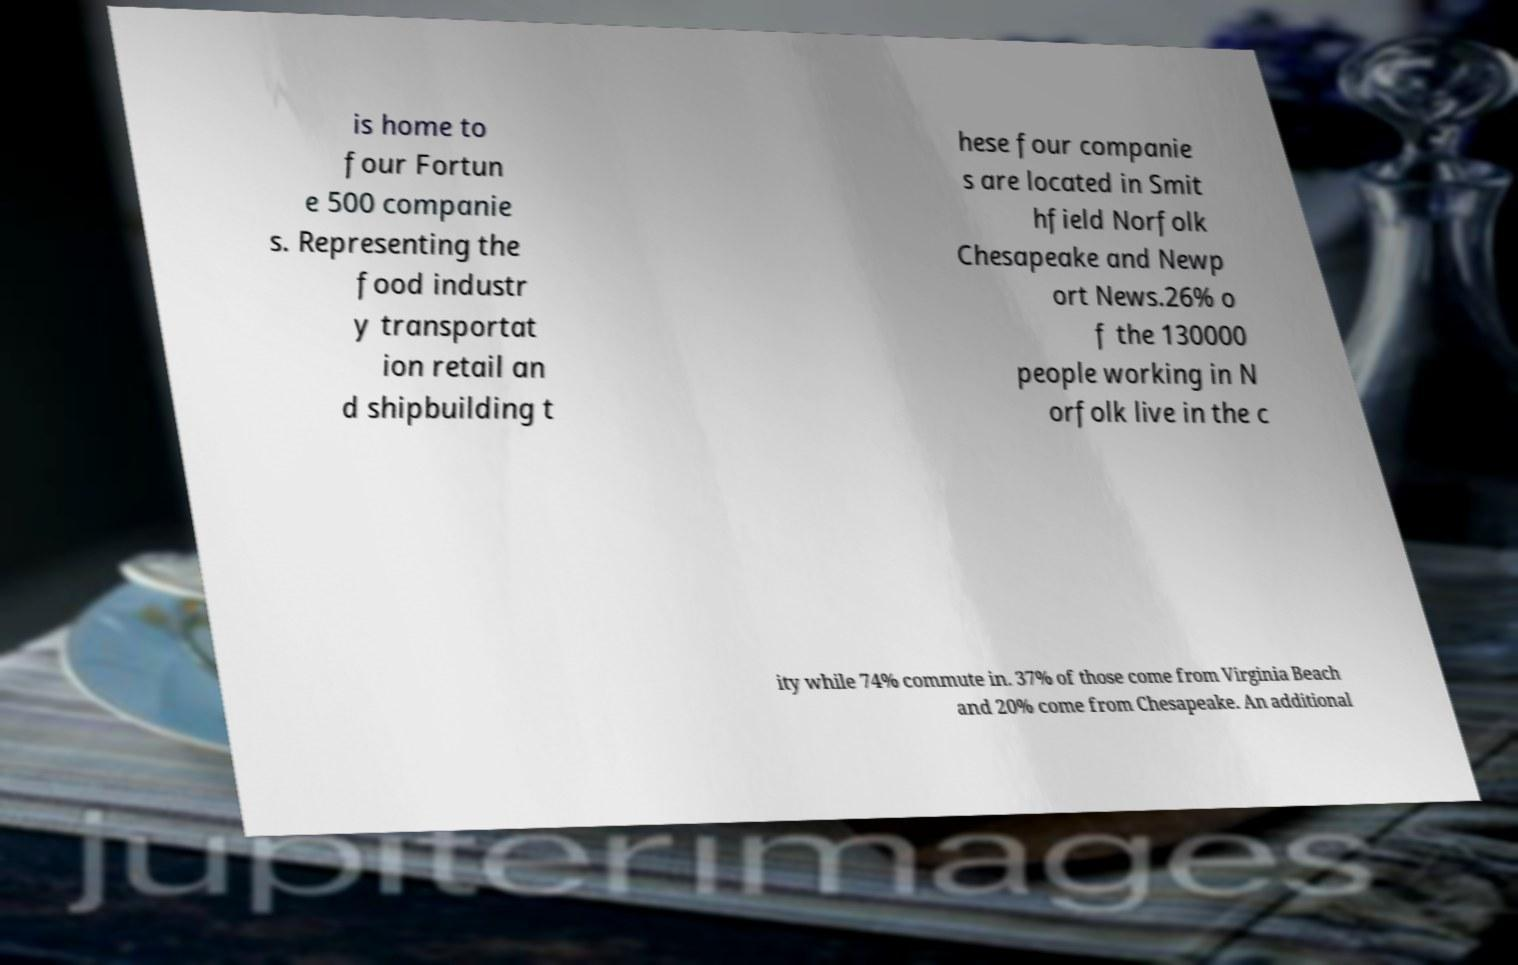There's text embedded in this image that I need extracted. Can you transcribe it verbatim? is home to four Fortun e 500 companie s. Representing the food industr y transportat ion retail an d shipbuilding t hese four companie s are located in Smit hfield Norfolk Chesapeake and Newp ort News.26% o f the 130000 people working in N orfolk live in the c ity while 74% commute in. 37% of those come from Virginia Beach and 20% come from Chesapeake. An additional 